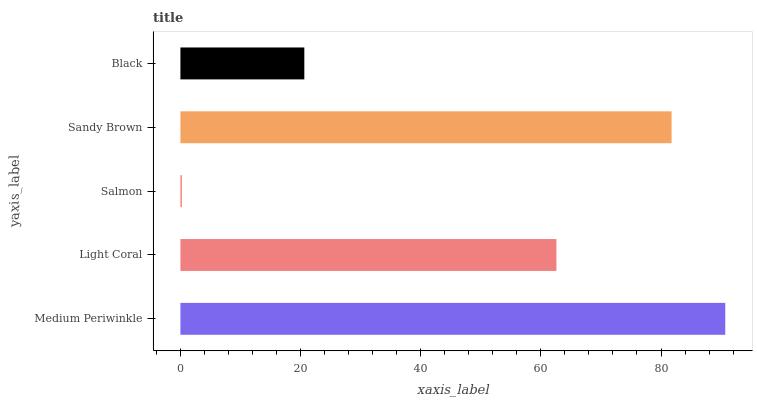Is Salmon the minimum?
Answer yes or no. Yes. Is Medium Periwinkle the maximum?
Answer yes or no. Yes. Is Light Coral the minimum?
Answer yes or no. No. Is Light Coral the maximum?
Answer yes or no. No. Is Medium Periwinkle greater than Light Coral?
Answer yes or no. Yes. Is Light Coral less than Medium Periwinkle?
Answer yes or no. Yes. Is Light Coral greater than Medium Periwinkle?
Answer yes or no. No. Is Medium Periwinkle less than Light Coral?
Answer yes or no. No. Is Light Coral the high median?
Answer yes or no. Yes. Is Light Coral the low median?
Answer yes or no. Yes. Is Black the high median?
Answer yes or no. No. Is Black the low median?
Answer yes or no. No. 